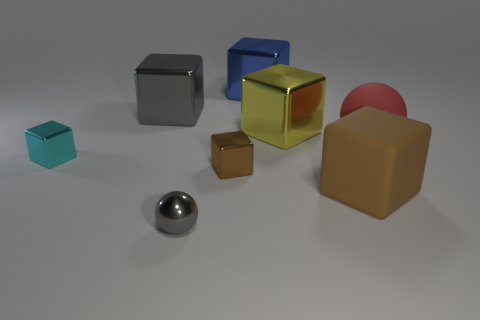Subtract all yellow shiny cubes. How many cubes are left? 5 Add 2 tiny brown metal things. How many objects exist? 10 Subtract 1 blocks. How many blocks are left? 5 Subtract all red spheres. Subtract all purple cubes. How many spheres are left? 1 Subtract all green balls. How many red cubes are left? 0 Subtract all purple shiny spheres. Subtract all shiny blocks. How many objects are left? 3 Add 7 small shiny blocks. How many small shiny blocks are left? 9 Add 7 big gray metal cubes. How many big gray metal cubes exist? 8 Subtract all cyan blocks. How many blocks are left? 5 Subtract 1 red balls. How many objects are left? 7 